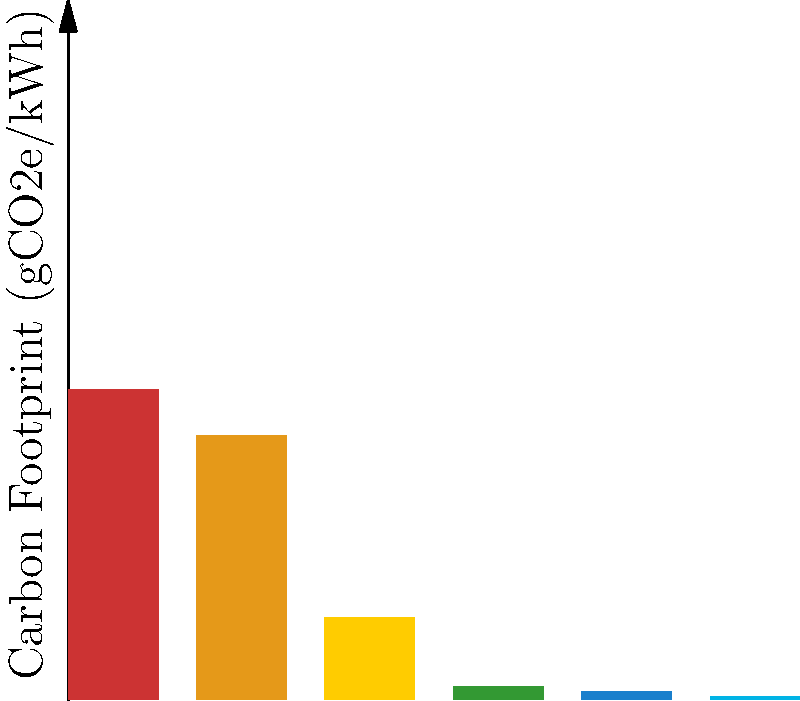Based on the bar graph showing the carbon footprint of different energy sources, which renewable energy source has the lowest carbon footprint, and how much lower is it compared to coal? To answer this question, we need to follow these steps:

1. Identify the renewable energy sources in the graph:
   - Solar PV
   - Wind
   - Hydroelectric

2. Compare the carbon footprint values of these renewable sources:
   - Solar PV: 230 gCO2e/kWh
   - Wind: 24 gCO2e/kWh
   - Hydroelectric: 11 gCO2e/kWh

3. Determine the renewable source with the lowest carbon footprint:
   Hydroelectric has the lowest at 11 gCO2e/kWh

4. Find the carbon footprint value for coal:
   Coal: 870 gCO2e/kWh

5. Calculate the difference between coal and hydroelectric:
   $$870 - 11 = 859 \text{ gCO2e/kWh}$$

6. Calculate the percentage difference:
   $$\frac{859}{870} \times 100 \approx 98.7\%$$

Therefore, hydroelectric power has the lowest carbon footprint among the renewable sources shown, and it is approximately 98.7% lower than coal.
Answer: Hydroelectric; 98.7% lower than coal 